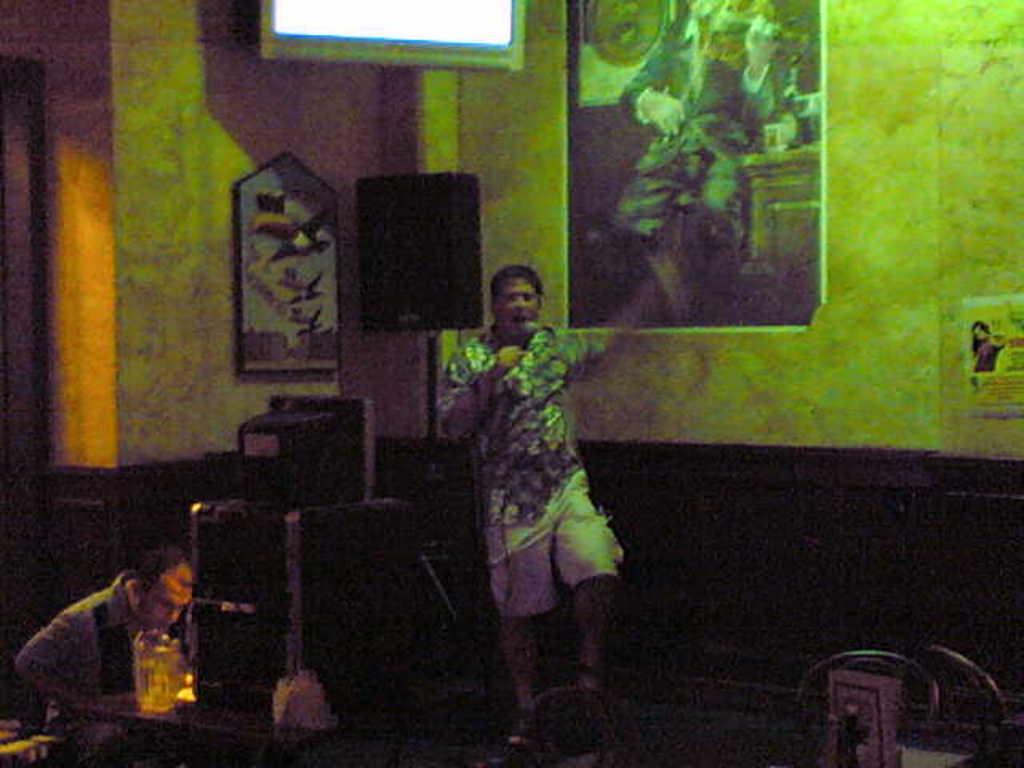Describe this image in one or two sentences. In this picture, we see a man is standing and he is holding the microphone in his hand. He might be singing on the microphone. Beside him, we see a speaker box and we see an object in black color. On the left side, we see a man sitting on the chair. In front of him, we see a table on which an object is placed. In the background, we see a wall on which the photo frames and a poster are placed. In the right bottom, we see an object. This picture might be clicked in the dark. 